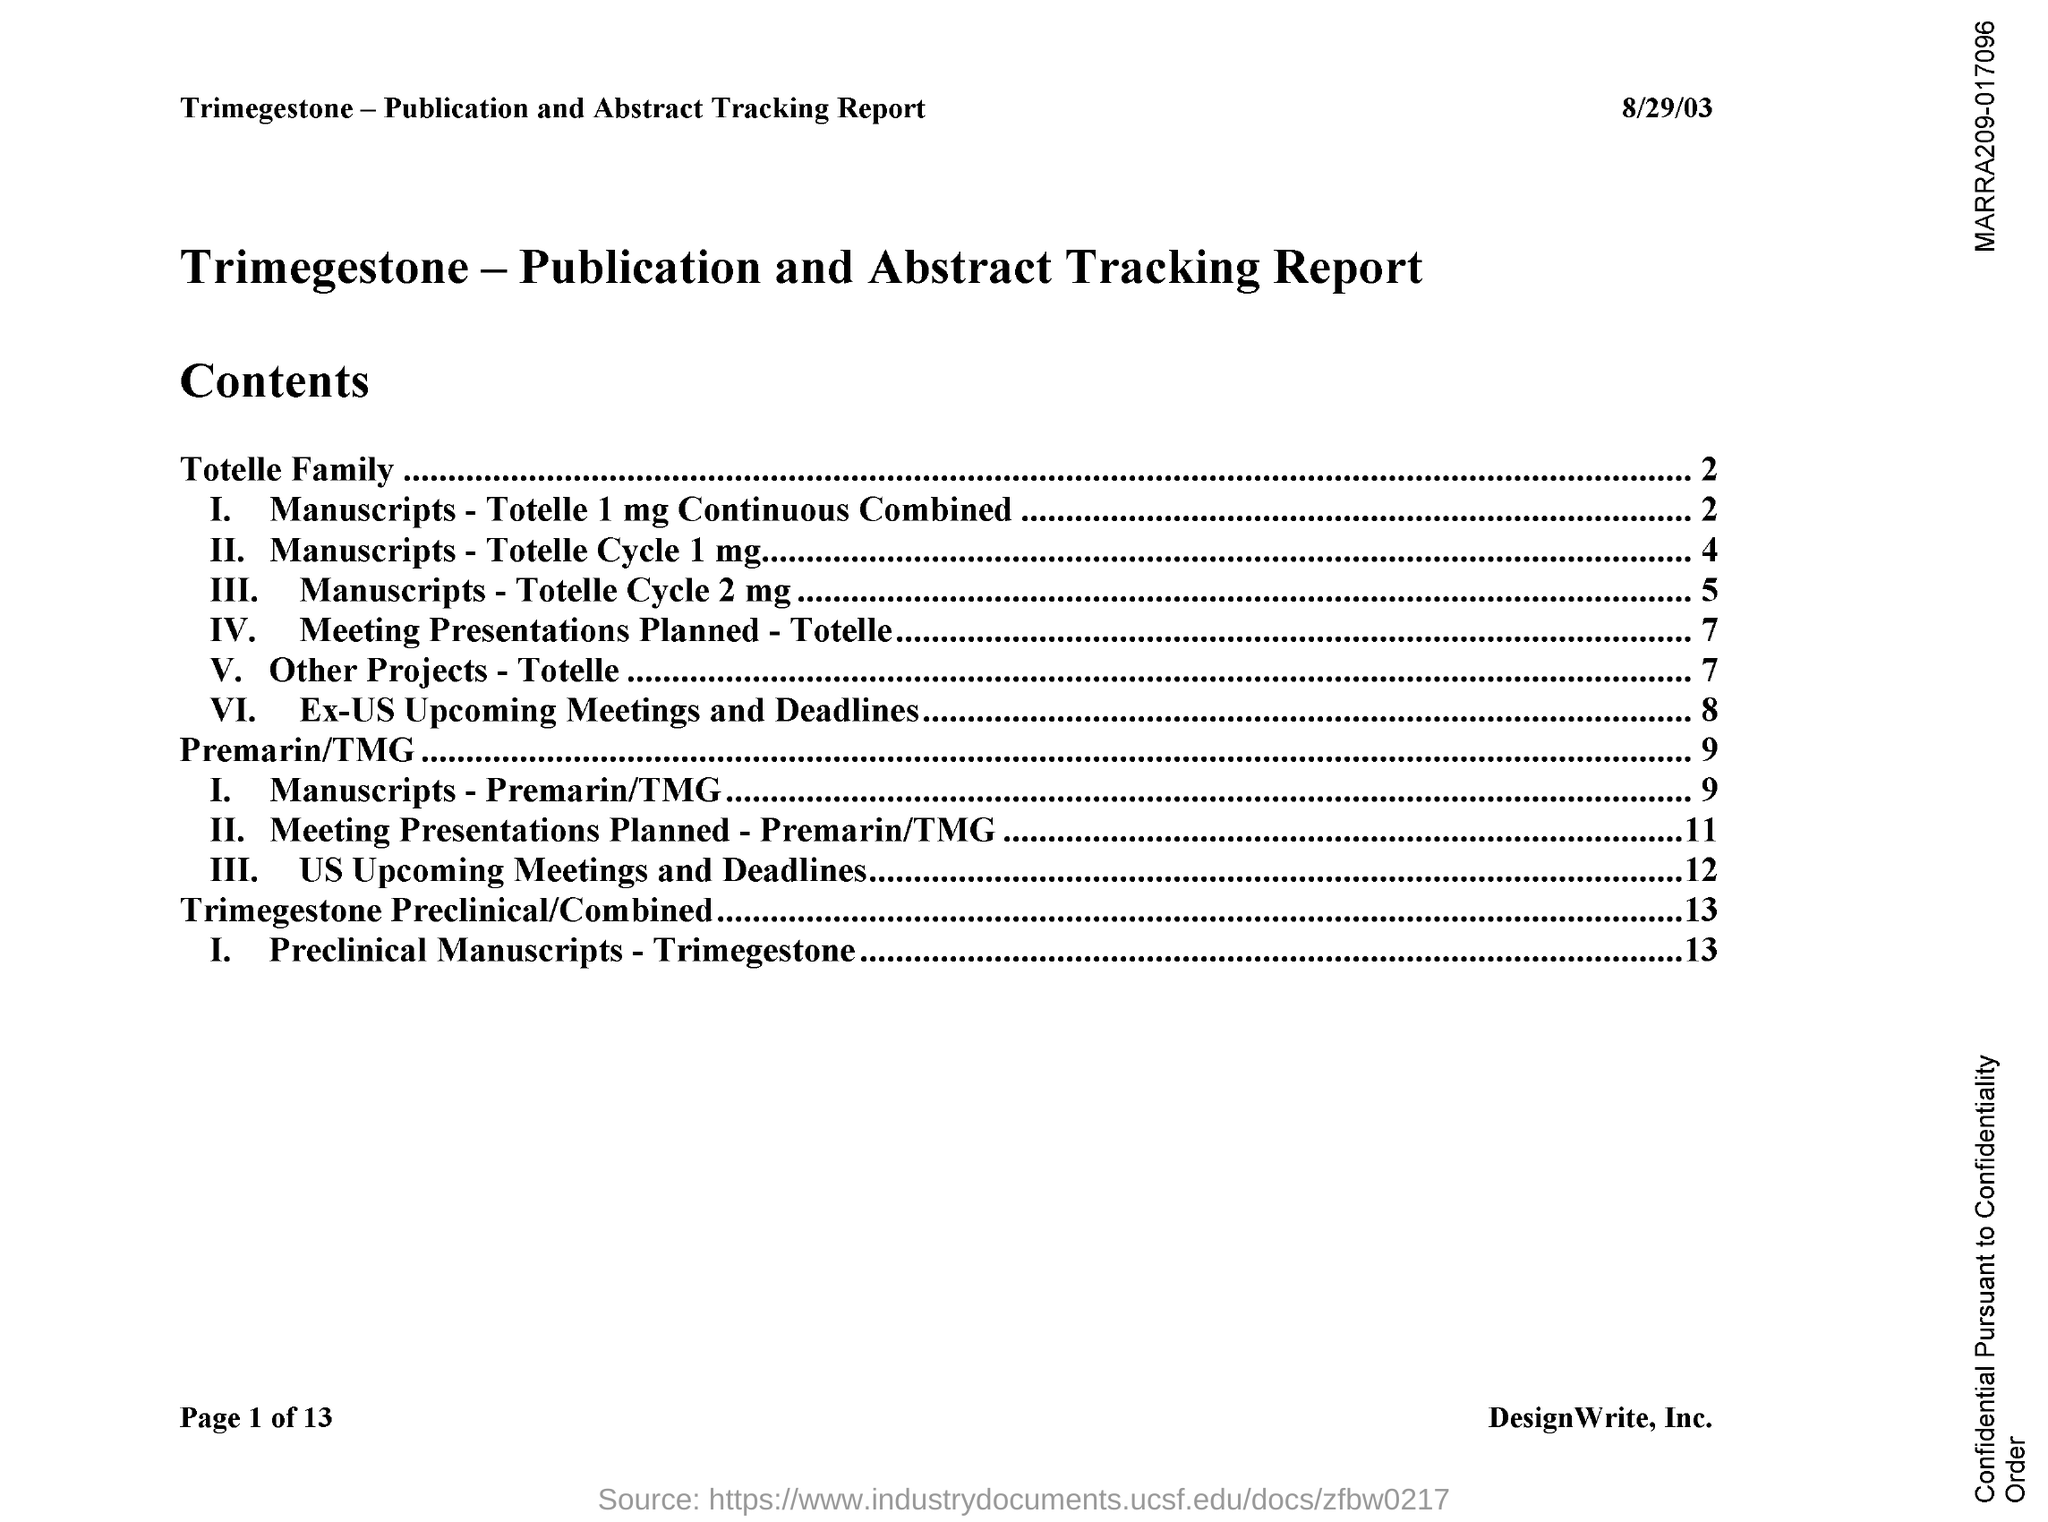What is the date mentioned in the document?
Your answer should be compact. 8/29/03. 